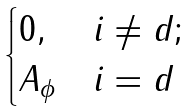Convert formula to latex. <formula><loc_0><loc_0><loc_500><loc_500>\begin{cases} 0 , & i \neq d ; \\ A _ { \phi } & i = d \end{cases}</formula> 